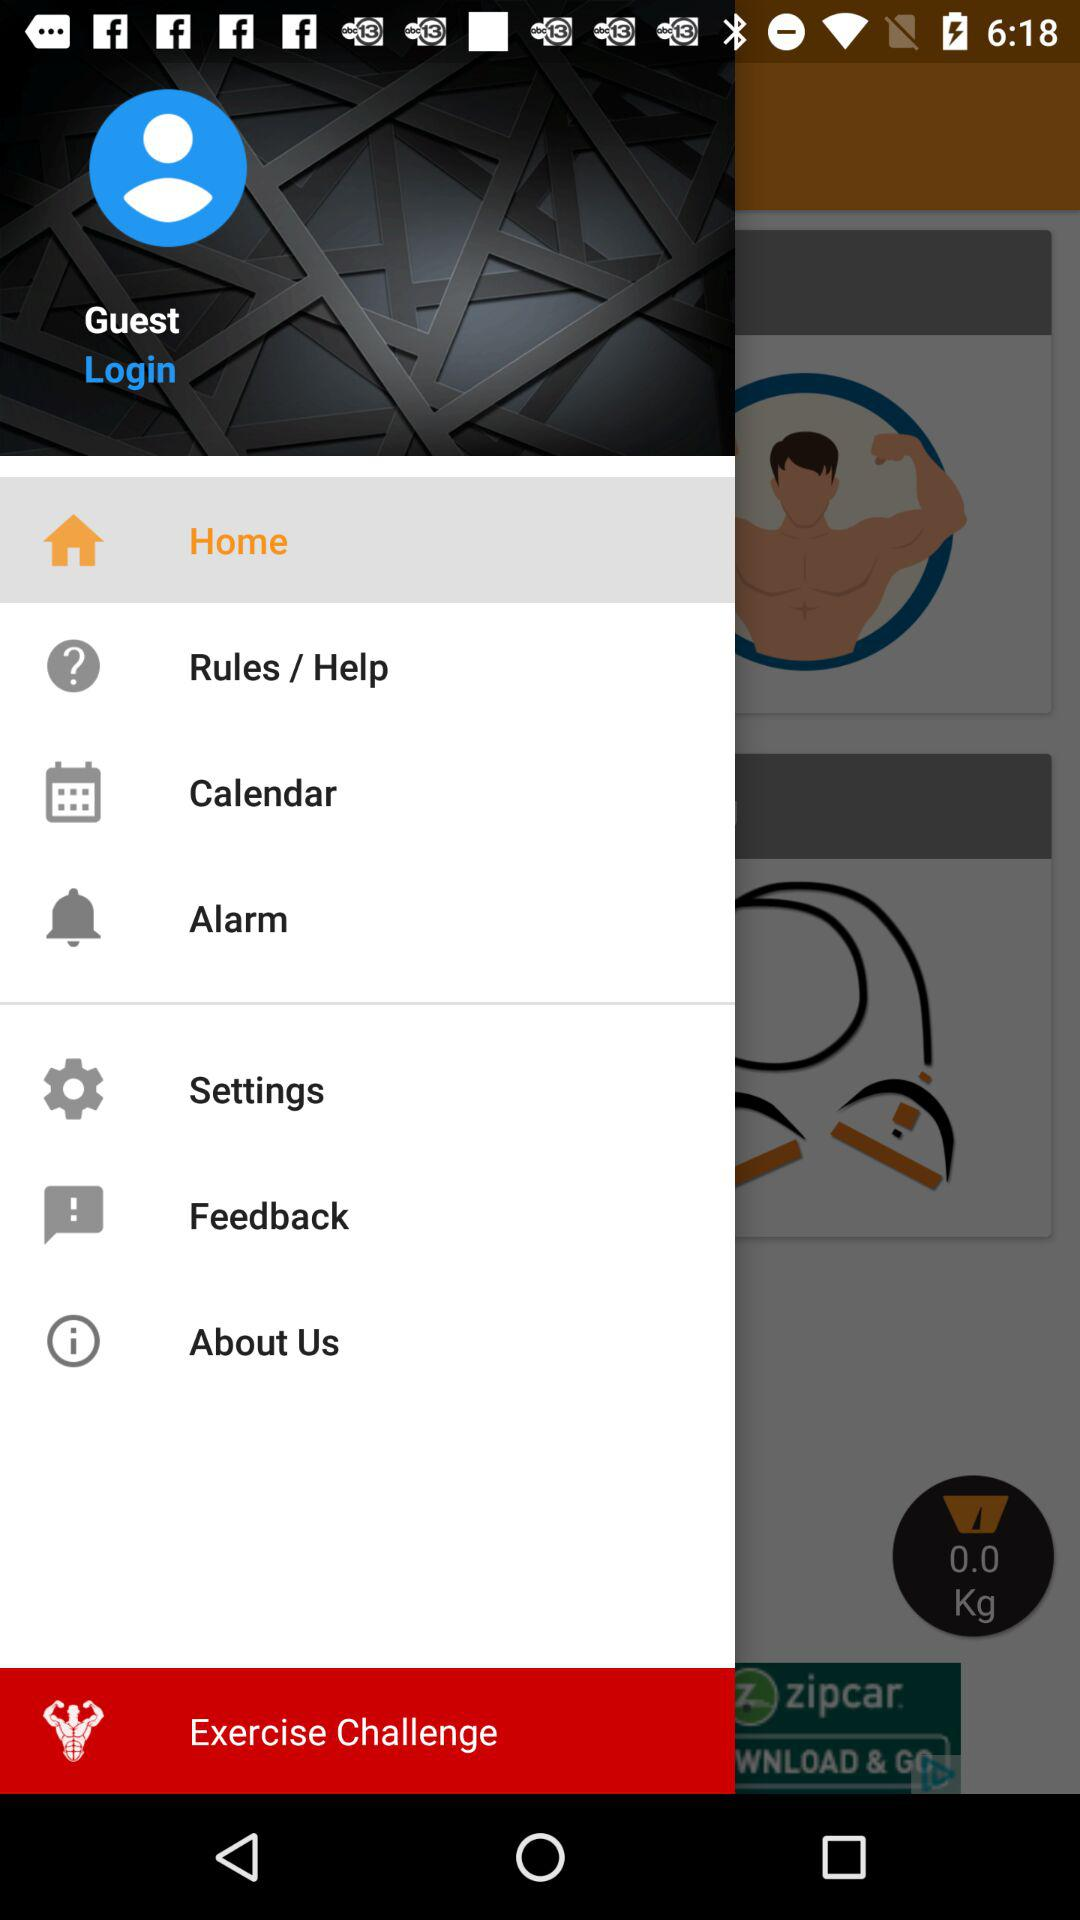Which item is selected from the menu? The selected item is "Home". 